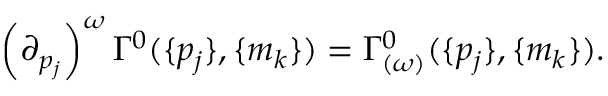Convert formula to latex. <formula><loc_0><loc_0><loc_500><loc_500>\left ( { \partial } _ { p _ { j } } \right ) ^ { \omega } \Gamma ^ { 0 } ( \{ p _ { j } \} , \{ m _ { k } \} ) = \Gamma _ { ( \omega ) } ^ { 0 } ( \{ p _ { j } \} , \{ m _ { k } \} ) .</formula> 